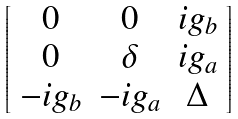Convert formula to latex. <formula><loc_0><loc_0><loc_500><loc_500>\left [ \begin{array} { c c c } 0 & 0 & i g _ { b } \\ 0 & \delta & i g _ { a } \\ - i g _ { b } & - i g _ { a } & \Delta \end{array} \right ]</formula> 